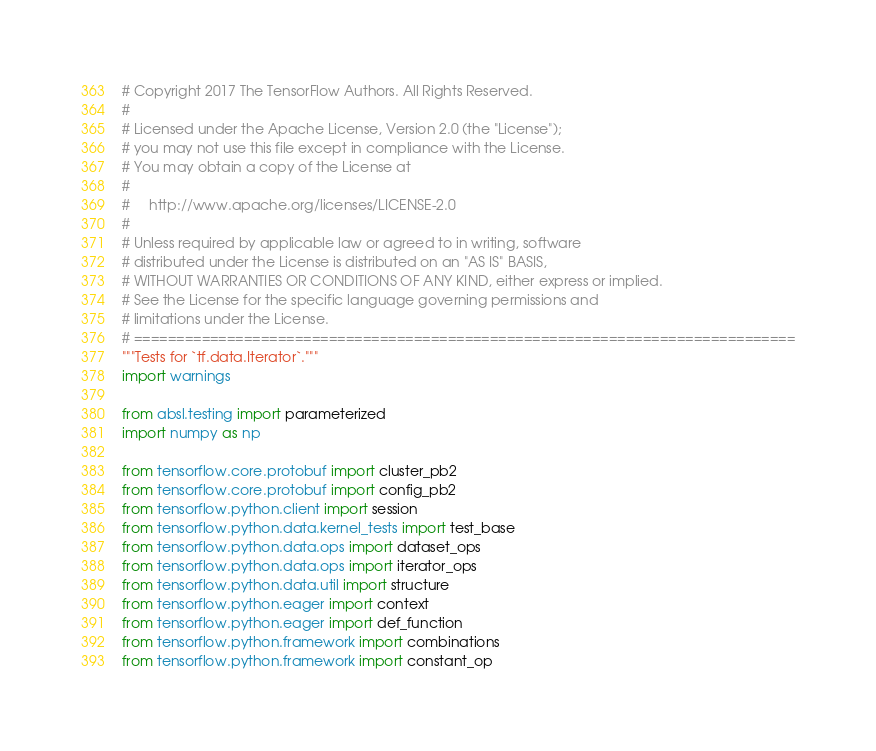<code> <loc_0><loc_0><loc_500><loc_500><_Python_># Copyright 2017 The TensorFlow Authors. All Rights Reserved.
#
# Licensed under the Apache License, Version 2.0 (the "License");
# you may not use this file except in compliance with the License.
# You may obtain a copy of the License at
#
#     http://www.apache.org/licenses/LICENSE-2.0
#
# Unless required by applicable law or agreed to in writing, software
# distributed under the License is distributed on an "AS IS" BASIS,
# WITHOUT WARRANTIES OR CONDITIONS OF ANY KIND, either express or implied.
# See the License for the specific language governing permissions and
# limitations under the License.
# ==============================================================================
"""Tests for `tf.data.Iterator`."""
import warnings

from absl.testing import parameterized
import numpy as np

from tensorflow.core.protobuf import cluster_pb2
from tensorflow.core.protobuf import config_pb2
from tensorflow.python.client import session
from tensorflow.python.data.kernel_tests import test_base
from tensorflow.python.data.ops import dataset_ops
from tensorflow.python.data.ops import iterator_ops
from tensorflow.python.data.util import structure
from tensorflow.python.eager import context
from tensorflow.python.eager import def_function
from tensorflow.python.framework import combinations
from tensorflow.python.framework import constant_op</code> 